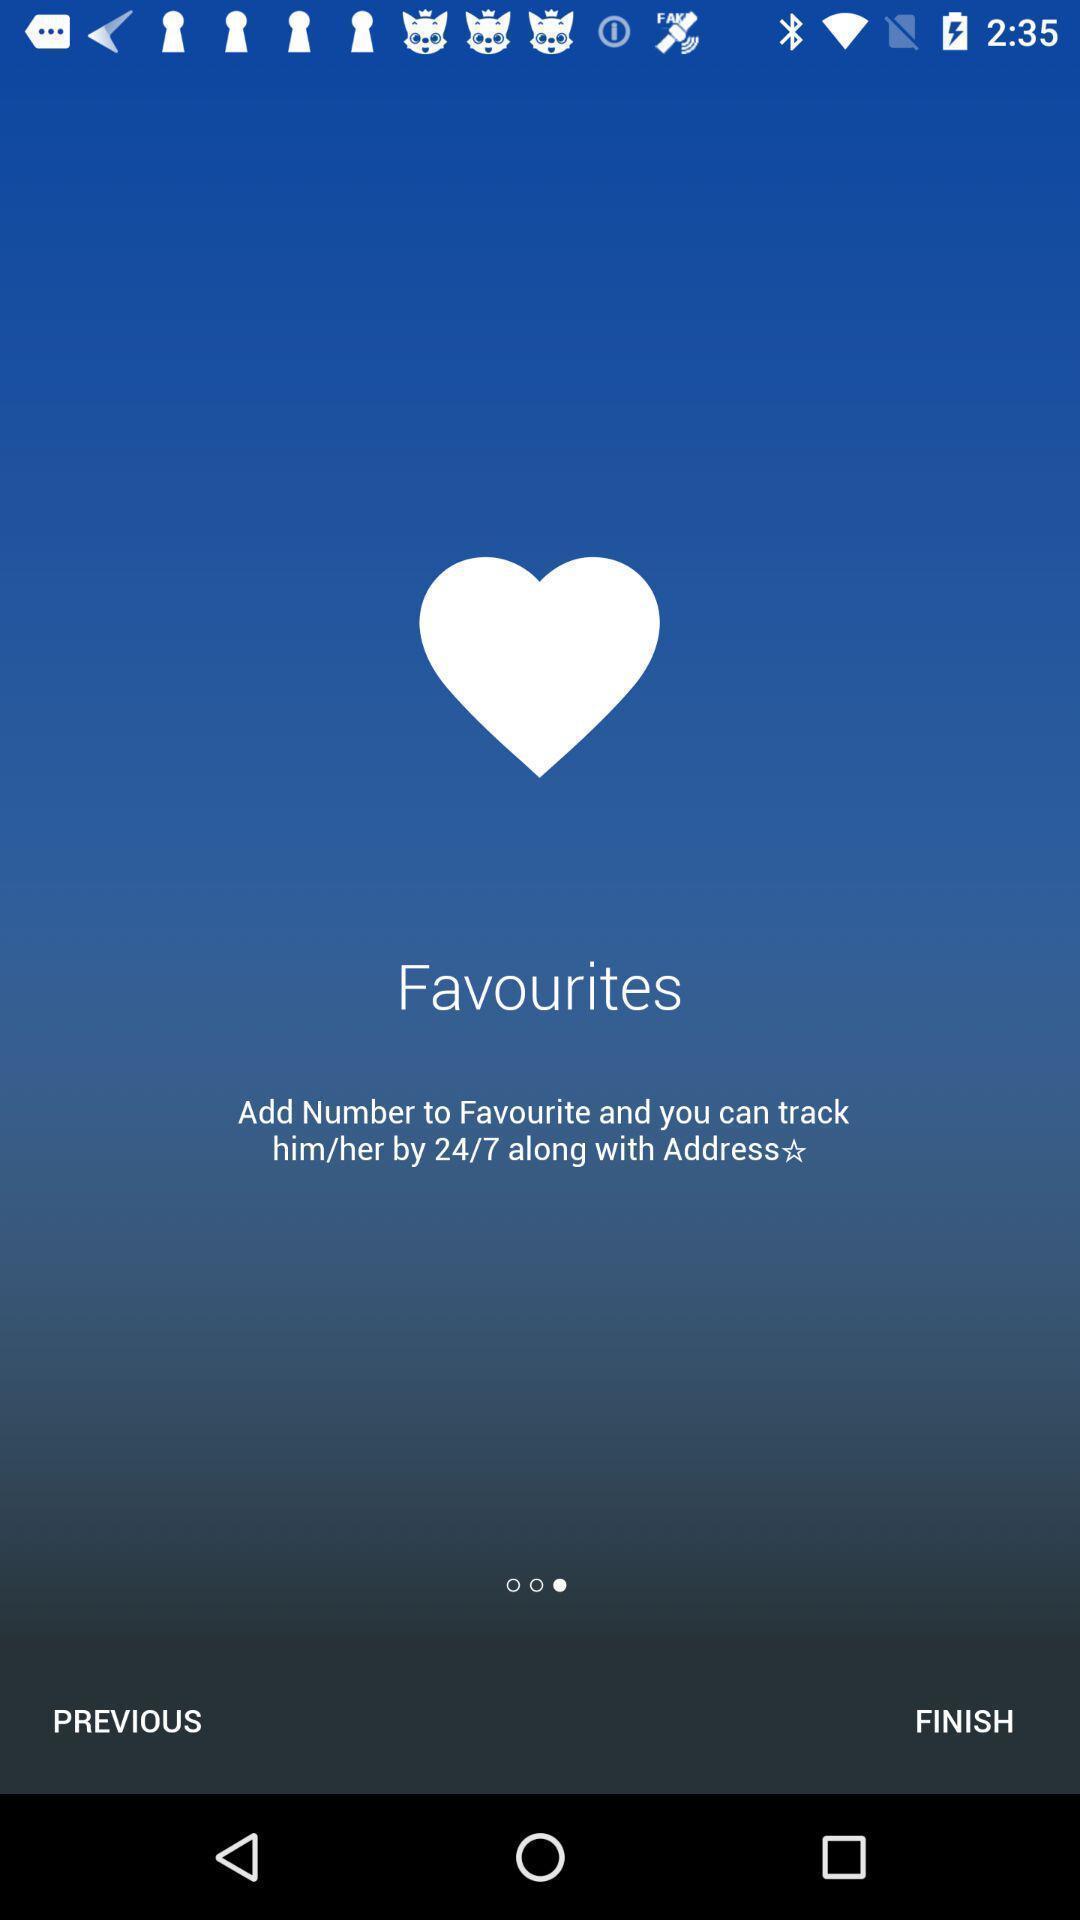What details can you identify in this image? Screen shows favourites. 